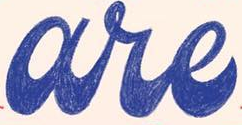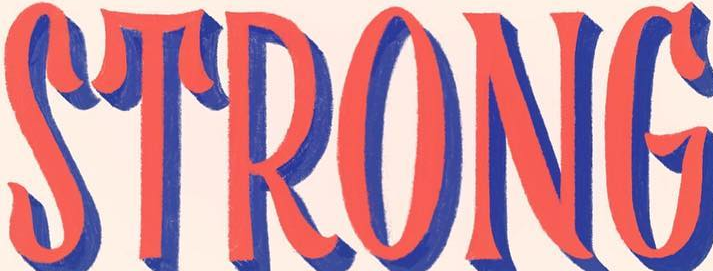Read the text from these images in sequence, separated by a semicolon. are; STRONG 